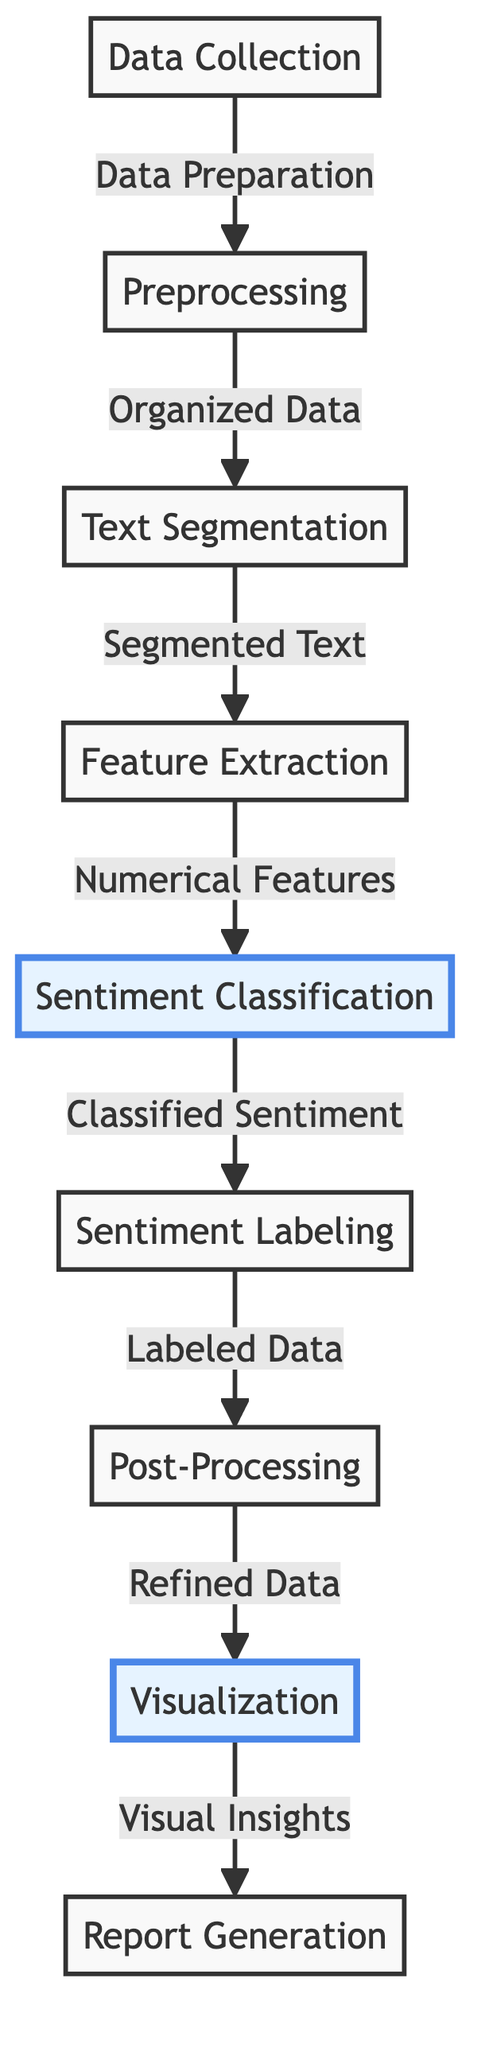What is the first step in the diagram? The first step in the diagram is "Data Collection," which indicates that the process begins with gathering relevant data for a sentiment analysis task.
Answer: Data Collection How many nodes are in the diagram? By counting each labeled box in the diagram, there are a total of eight distinct nodes represented throughout the flow.
Answer: 8 What follows after Preprocessing? The node that follows "Preprocessing" in the workflow is "Text Segmentation," which indicates the step that comes next after data preparation.
Answer: Text Segmentation What is the final step in the process? The last step indicated in the diagram is "Report Generation," signifying the end of the sentiment analysis process where findings are compiled and presented.
Answer: Report Generation Which nodes are emphasized in the diagram? The nodes that are emphasized in the diagram are "Sentiment Classification" and "Visualization," highlighting their significance in the analysis process.
Answer: Sentiment Classification, Visualization Which node produces visual insights? The "Visualization" node is responsible for generating visual insights based on the classified and processed sentiment data.
Answer: Visualization What is the output of the "Sentiment Classification" node? The output from the "Sentiment Classification" node is "Classified Sentiment," indicating the results of the sentiment analysis at this stage.
Answer: Classified Sentiment What type of insights does the "Visualization" node provide? The "Visualization" node provides "Visual Insights," which typically involves graphical representations of the sentiment data analyzed previously.
Answer: Visual Insights What is the relationship between "Feature Extraction" and "Sentiment Classification"? "Feature Extraction" feeds into "Sentiment Classification," meaning the numerical features extracted from text are used to classify sentiments.
Answer: Feature Extraction --> Sentiment Classification 